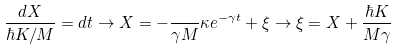Convert formula to latex. <formula><loc_0><loc_0><loc_500><loc_500>\frac { d X } { \hbar { K } / M } = d t \rightarrow X = - \frac { } { \gamma M } \kappa e ^ { - \gamma t } + \xi \rightarrow \xi = X + \frac { \hbar { K } } { M \gamma }</formula> 